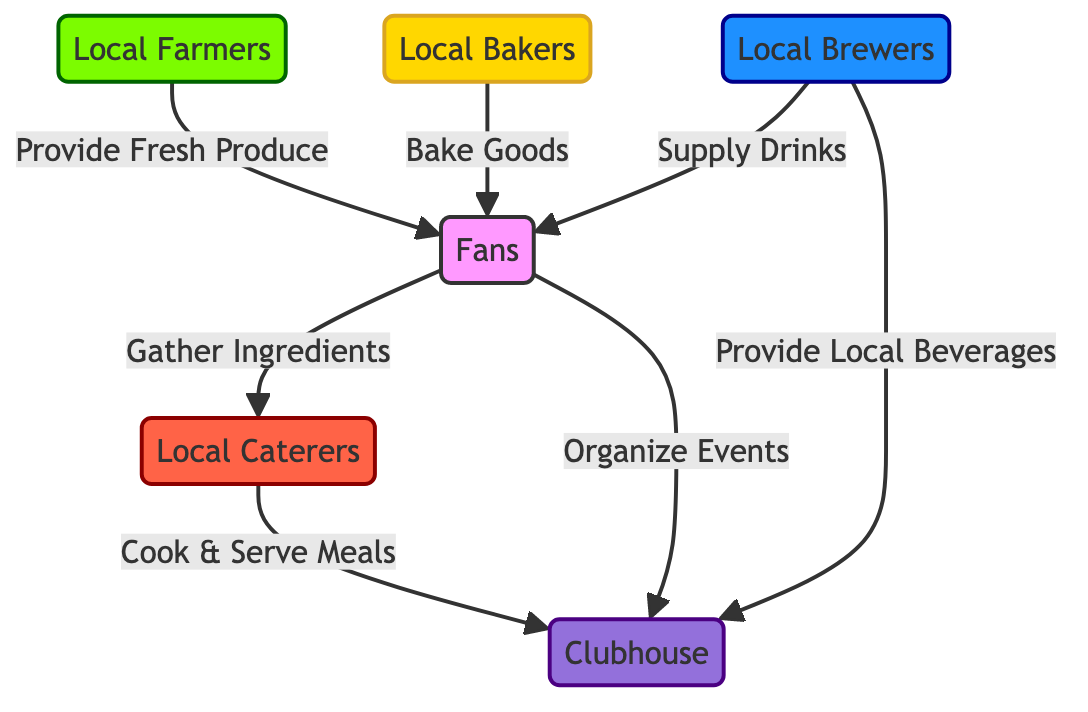What are the two main contributors to the fans? The diagram shows that local farmers provide fresh produce and local bakers bake goods, both of which contribute to the fans.
Answer: Fresh Produce, Baked Goods How many nodes are in the food chain diagram? By counting each unique entity depicted in the diagram including local farmers, local bakers, local brewers, fans, local caterers, and clubhouse, we find there are six nodes.
Answer: 6 What do fans gather for the local caterers? The diagram indicates that fans gather ingredients for the local caterers to use in meal preparation.
Answer: Ingredients Who provides local beverages to the clubhouse? According to the diagram, local brewers are responsible for providing local beverages to the clubhouse.
Answer: Local Brewers What role do local caterers play in the food chain? The diagram makes it clear that local caterers cook and serve meals to the clubhouse, thus highlighting their role as meal preparers.
Answer: Cook & Serve Meals How many roles do fans have in this food chain? From the diagram, fans have two roles: gathering ingredients for local caterers and organizing events for the clubhouse, indicating dual contributions.
Answer: 2 What is the final destination of the food chain? The diagram shows that the food ultimately ends at the clubhouse, labeled as the final destination of this food chain process.
Answer: Clubhouse Which two elements have a direct connection to the clubhouse? The diagram illustrates that local caterers and local brewers both have direct connections to the clubhouse.
Answer: Local Caterers, Local Brewers What color represents local farmers in the diagram? The color associated with the local farmers in the diagram is a shade of green, specifically the fill color #7cfc00.
Answer: Green 